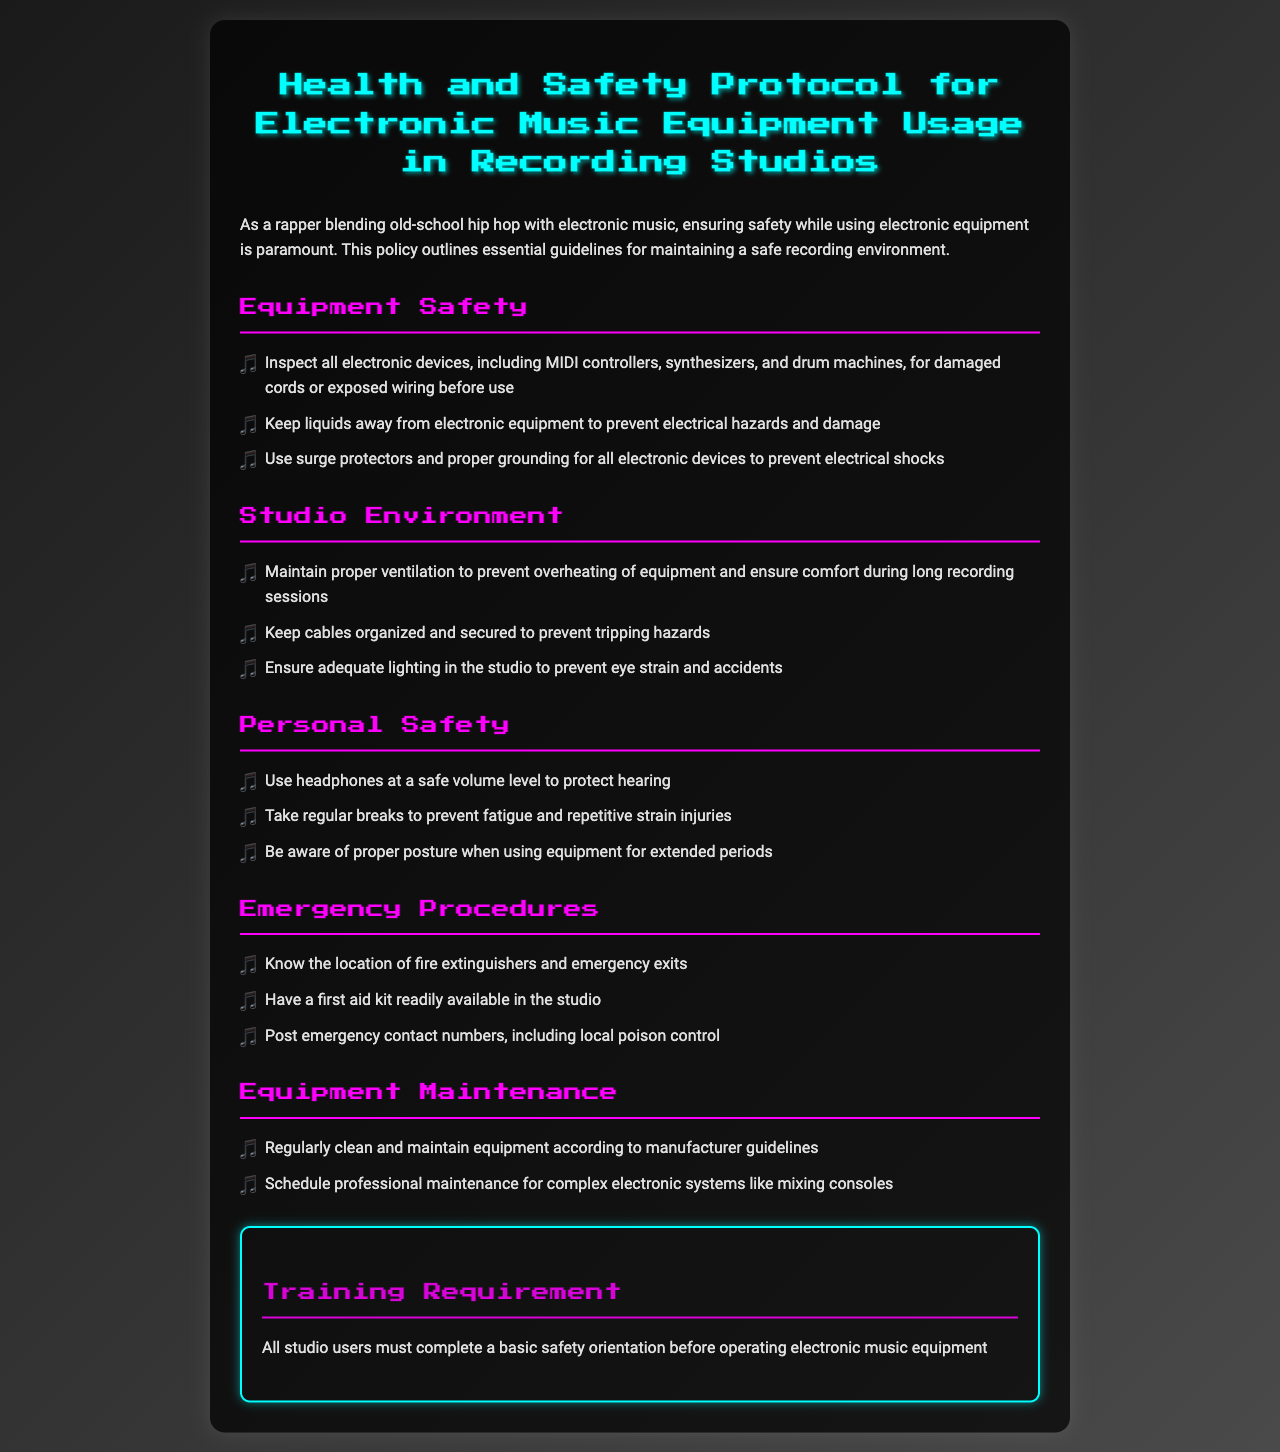what is the title of the document? The title of the document is clearly stated at the top of the first section in a large font.
Answer: Health and Safety Protocol for Electronic Music Equipment Usage in Recording Studios how many sections are in the document? The document is divided into several key sections as listed under the main title.
Answer: 6 what should you keep away from electronic equipment? This guideline aims to prevent hazards associated with moisture affecting electronic devices.
Answer: Liquids what is required before operating electronic music equipment? The document specifies an important prerequisite that all users must fulfill before usage.
Answer: Basic safety orientation what should be used to prevent electrical hazards? This principle is crucial to maintaining safety while using electronic devices in the studio.
Answer: Surge protectors where should emergency contact numbers be posted? This recommendation is crucial for quick access in urgent situations within the studio environment.
Answer: In the studio 